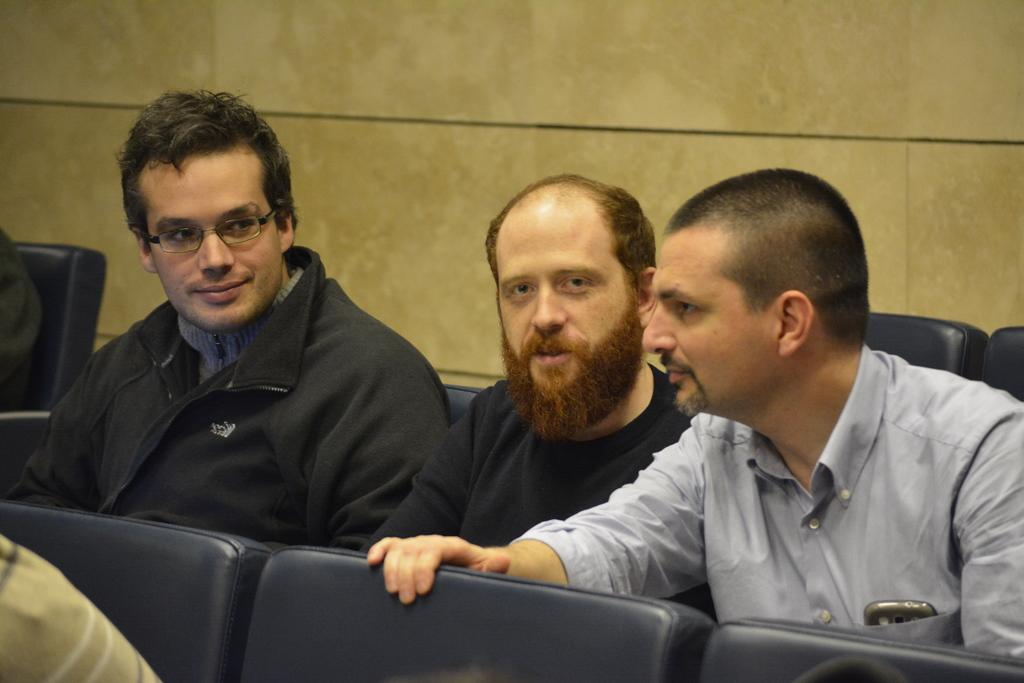Who is present in the image? There are men in the image. What are the men doing in the image? The men are sitting on chairs. What type of tooth is visible in the image? There is no tooth present in the image; it features men sitting on chairs. 